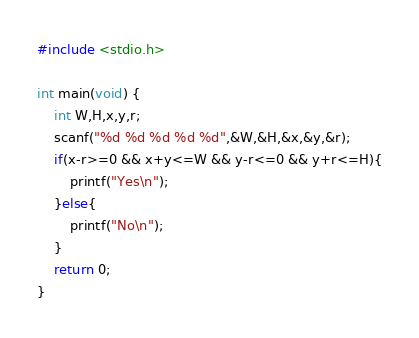Convert code to text. <code><loc_0><loc_0><loc_500><loc_500><_C_>#include <stdio.h>
 
int main(void) {
    int W,H,x,y,r;
    scanf("%d %d %d %d %d",&W,&H,&x,&y,&r);
    if(x-r>=0 && x+y<=W && y-r<=0 && y+r<=H){
        printf("Yes\n");
    }else{
        printf("No\n");
    }
    return 0;
}</code> 